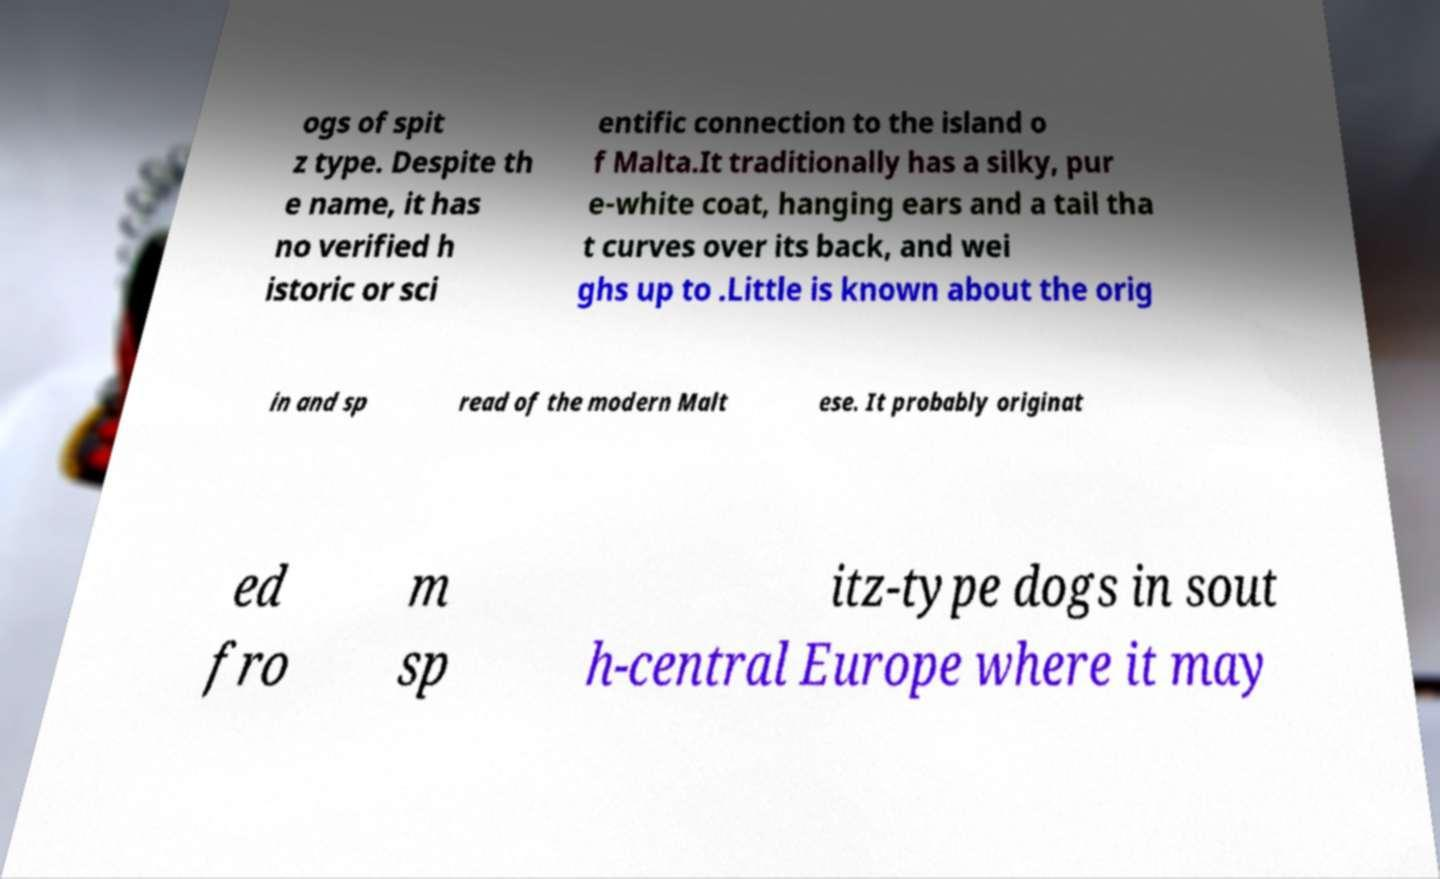Could you assist in decoding the text presented in this image and type it out clearly? ogs of spit z type. Despite th e name, it has no verified h istoric or sci entific connection to the island o f Malta.It traditionally has a silky, pur e-white coat, hanging ears and a tail tha t curves over its back, and wei ghs up to .Little is known about the orig in and sp read of the modern Malt ese. It probably originat ed fro m sp itz-type dogs in sout h-central Europe where it may 